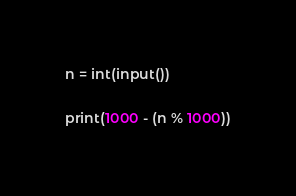Convert code to text. <code><loc_0><loc_0><loc_500><loc_500><_Python_>n = int(input())

print(1000 - (n % 1000))</code> 